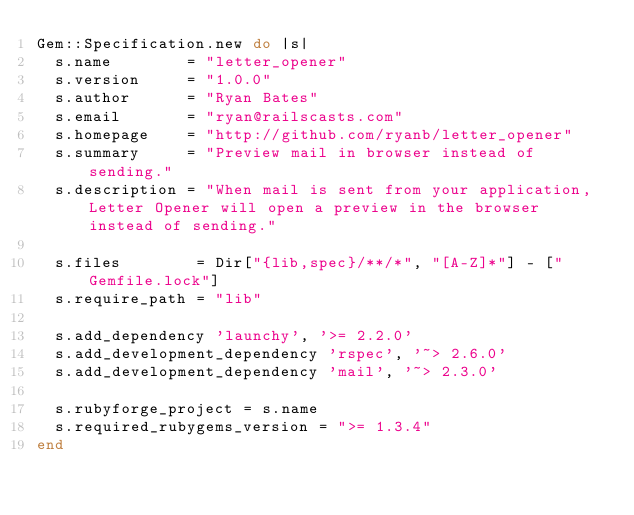<code> <loc_0><loc_0><loc_500><loc_500><_Ruby_>Gem::Specification.new do |s|
  s.name        = "letter_opener"
  s.version     = "1.0.0"
  s.author      = "Ryan Bates"
  s.email       = "ryan@railscasts.com"
  s.homepage    = "http://github.com/ryanb/letter_opener"
  s.summary     = "Preview mail in browser instead of sending."
  s.description = "When mail is sent from your application, Letter Opener will open a preview in the browser instead of sending."

  s.files        = Dir["{lib,spec}/**/*", "[A-Z]*"] - ["Gemfile.lock"]
  s.require_path = "lib"

  s.add_dependency 'launchy', '>= 2.2.0'
  s.add_development_dependency 'rspec', '~> 2.6.0'
  s.add_development_dependency 'mail', '~> 2.3.0'

  s.rubyforge_project = s.name
  s.required_rubygems_version = ">= 1.3.4"
end
</code> 